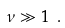Convert formula to latex. <formula><loc_0><loc_0><loc_500><loc_500>\nu \gg 1 \ .</formula> 